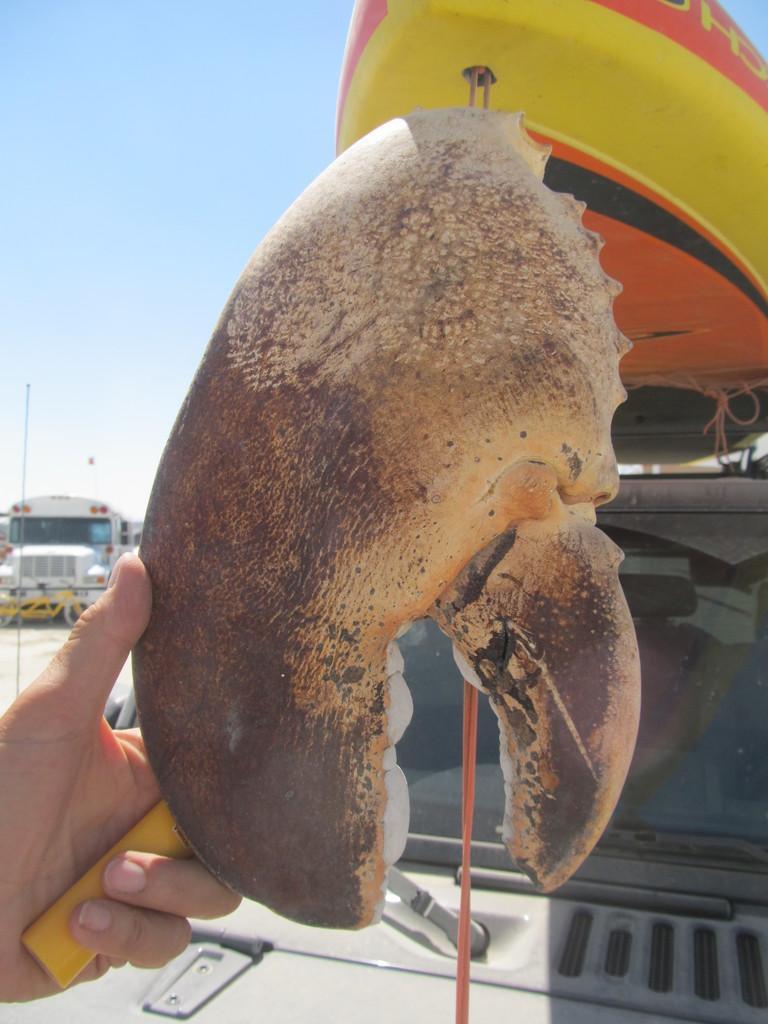Can you describe this image briefly? In this image, we can see a person’s hand holding some objects. There are a few vehicles. We can see a boat, a pole and the ground. We can also see some objects on the left. We can also see the sky. 